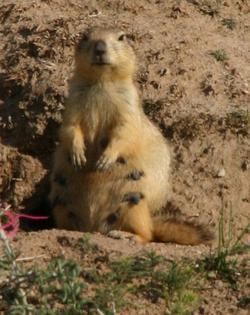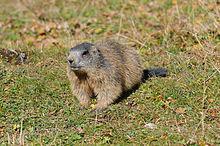The first image is the image on the left, the second image is the image on the right. For the images displayed, is the sentence "There are two animals total." factually correct? Answer yes or no. Yes. The first image is the image on the left, the second image is the image on the right. Evaluate the accuracy of this statement regarding the images: "Right image shows a non-upright marmot with lifted head facing rightward.". Is it true? Answer yes or no. No. 